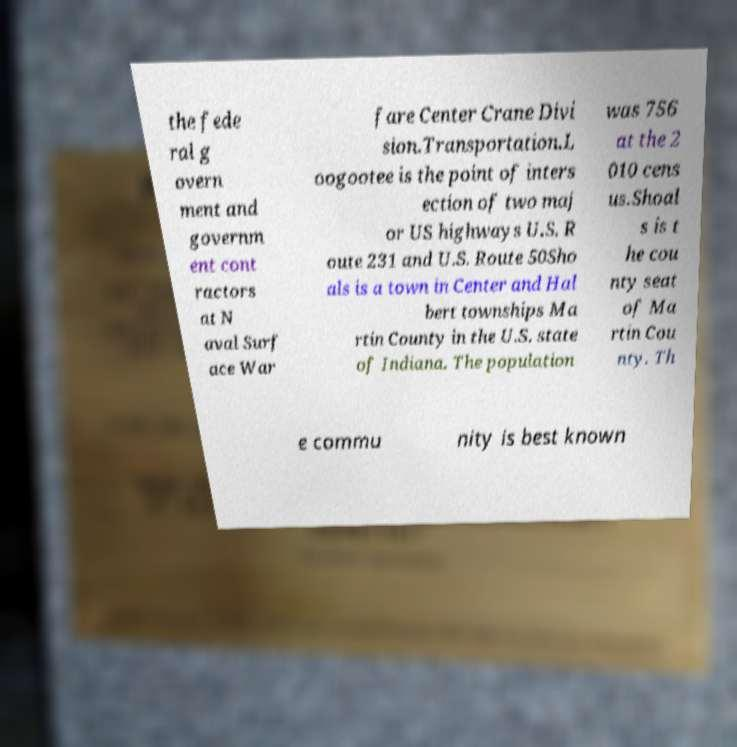Can you read and provide the text displayed in the image?This photo seems to have some interesting text. Can you extract and type it out for me? the fede ral g overn ment and governm ent cont ractors at N aval Surf ace War fare Center Crane Divi sion.Transportation.L oogootee is the point of inters ection of two maj or US highways U.S. R oute 231 and U.S. Route 50Sho als is a town in Center and Hal bert townships Ma rtin County in the U.S. state of Indiana. The population was 756 at the 2 010 cens us.Shoal s is t he cou nty seat of Ma rtin Cou nty. Th e commu nity is best known 